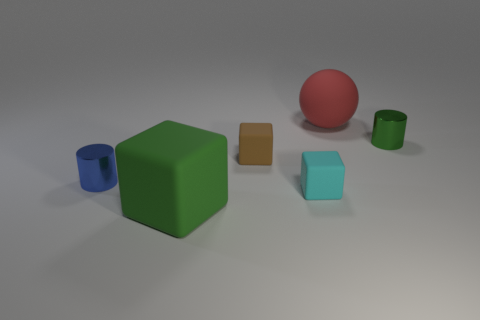Are there any reflections or notable details on the surfaces of the objects that describe the environment around them? From the image, the reflections are minimal, but there's a gentle glow on the objects that suggests the presence of a broad and diffuse light source nearby. The lack of distinct reflections indicates that the surrounding environment might be simple and does not have many elements to cast distinct reflections on these objects. The subtle details in the highlights and shadows on their surfaces tell us mostly about their shapes and textures rather than the surrounding space. 